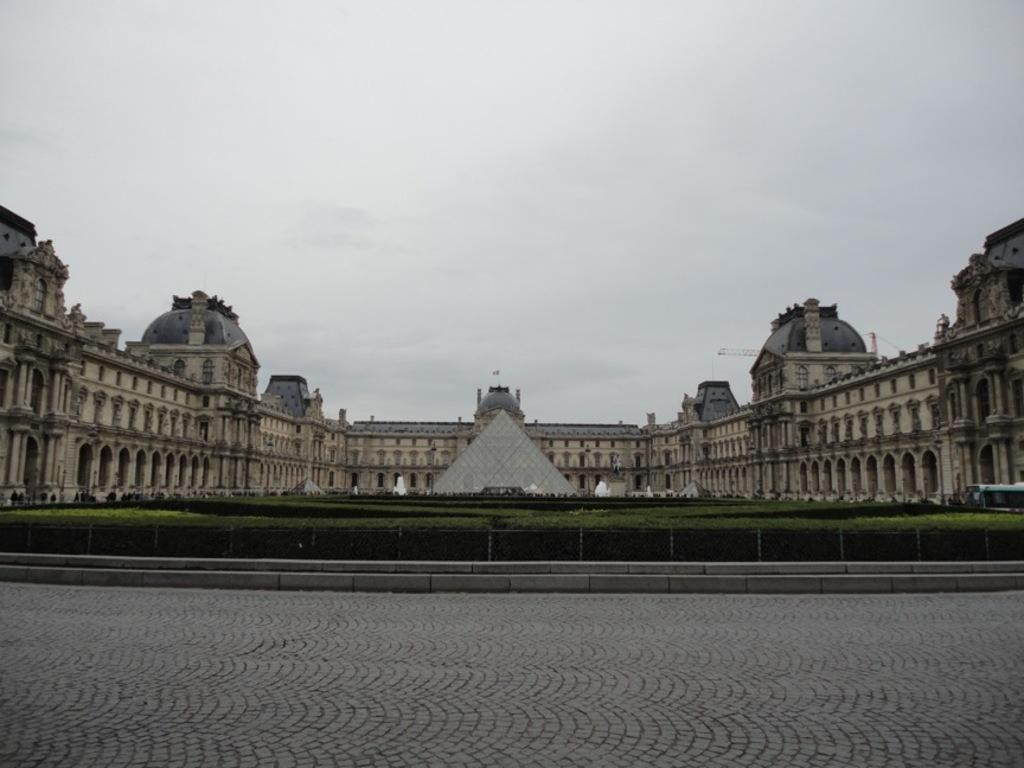What type of structure is visible in the image? There is a building in the image. What is located in front of the building? There is a pyramid in front of the building. What type of vegetation can be seen in the image? There are many plants in the image. What type of theory is being discussed in the image? There is no discussion or theory present in the image; it features a building, a pyramid, and plants. How many oranges are visible in the image? There are no oranges present in the image. 